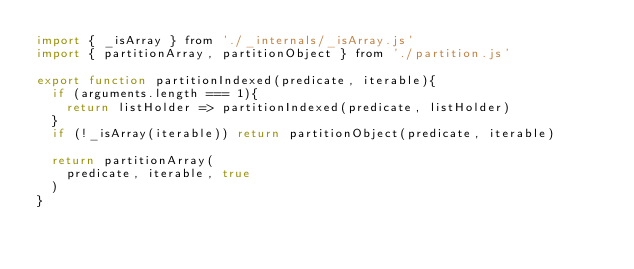<code> <loc_0><loc_0><loc_500><loc_500><_JavaScript_>import { _isArray } from './_internals/_isArray.js'
import { partitionArray, partitionObject } from './partition.js'

export function partitionIndexed(predicate, iterable){
  if (arguments.length === 1){
    return listHolder => partitionIndexed(predicate, listHolder)
  }
  if (!_isArray(iterable)) return partitionObject(predicate, iterable)

  return partitionArray(
    predicate, iterable, true
  )
}
</code> 